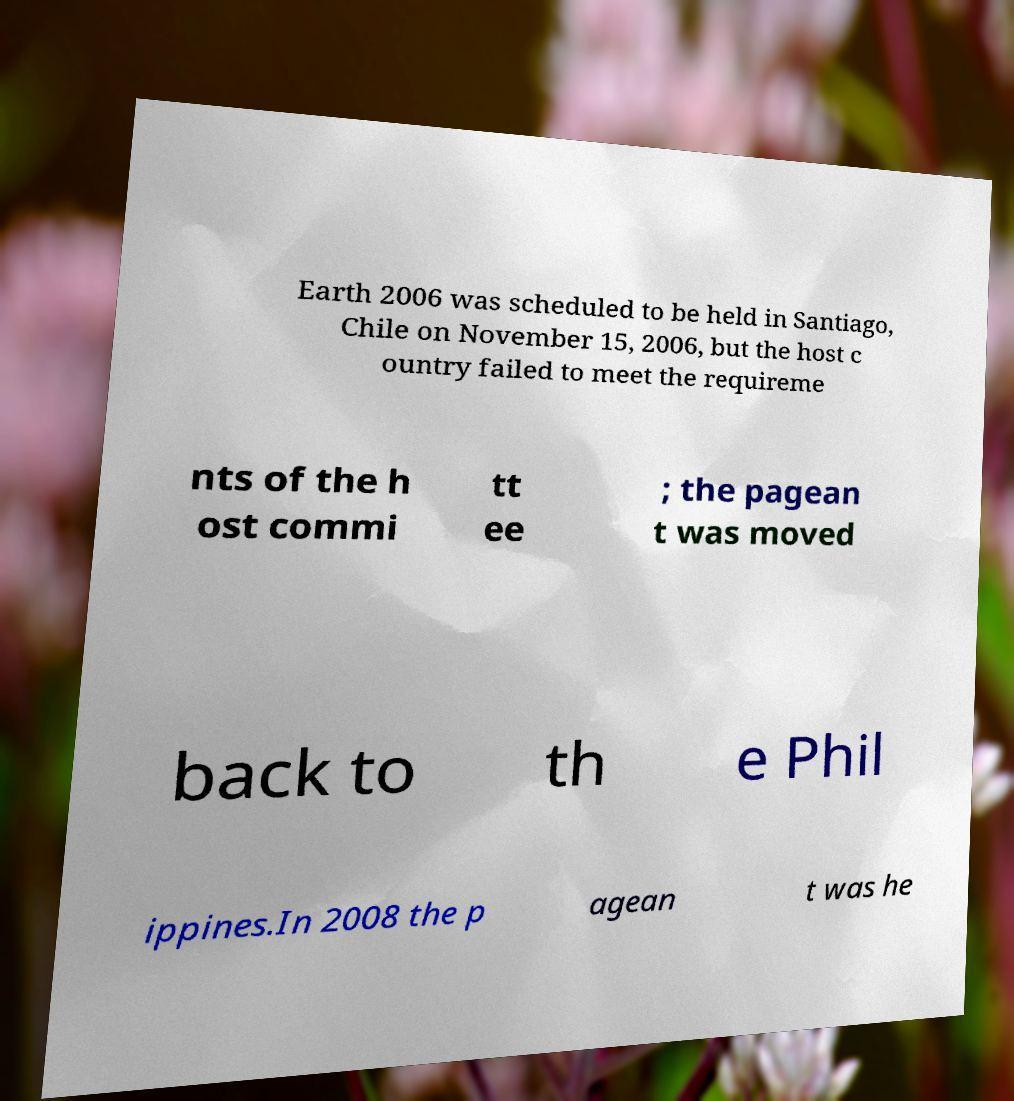Can you read and provide the text displayed in the image?This photo seems to have some interesting text. Can you extract and type it out for me? Earth 2006 was scheduled to be held in Santiago, Chile on November 15, 2006, but the host c ountry failed to meet the requireme nts of the h ost commi tt ee ; the pagean t was moved back to th e Phil ippines.In 2008 the p agean t was he 